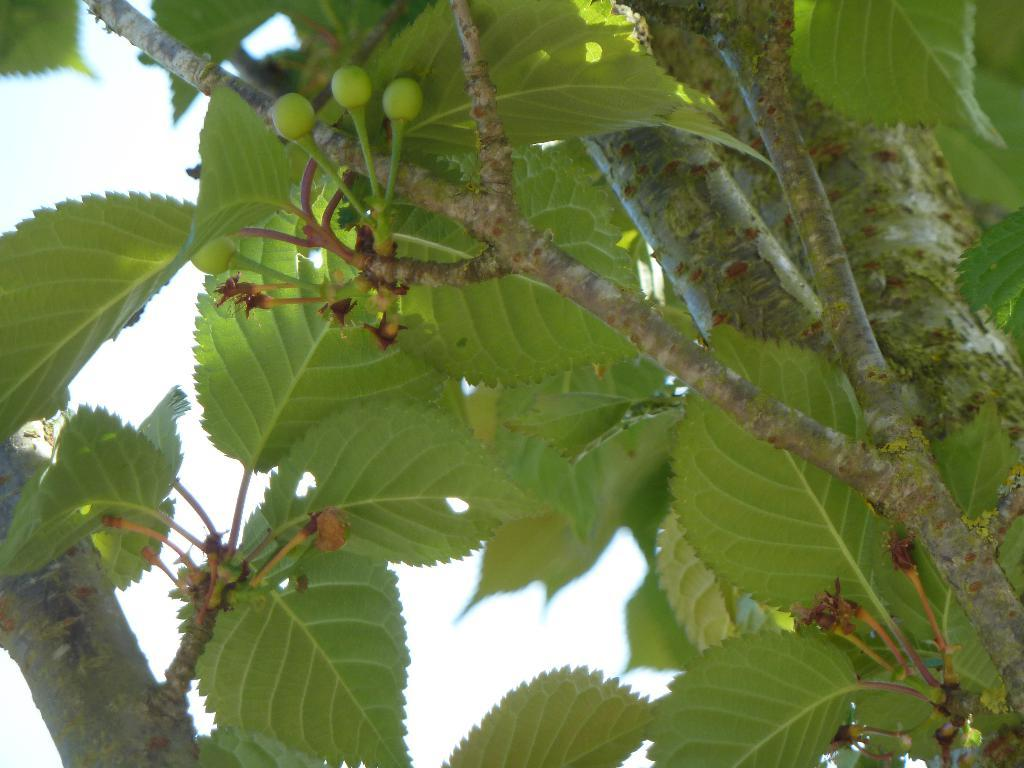What type of plant parts can be seen in the image? There are branches and leaves in the image. To which plant do the branches and leaves belong? The branches and leaves belong to a tree. What type of suit can be seen hanging on the branches of the tree in the image? There is no suit present in the image; it only features branches and leaves belonging to a tree. 